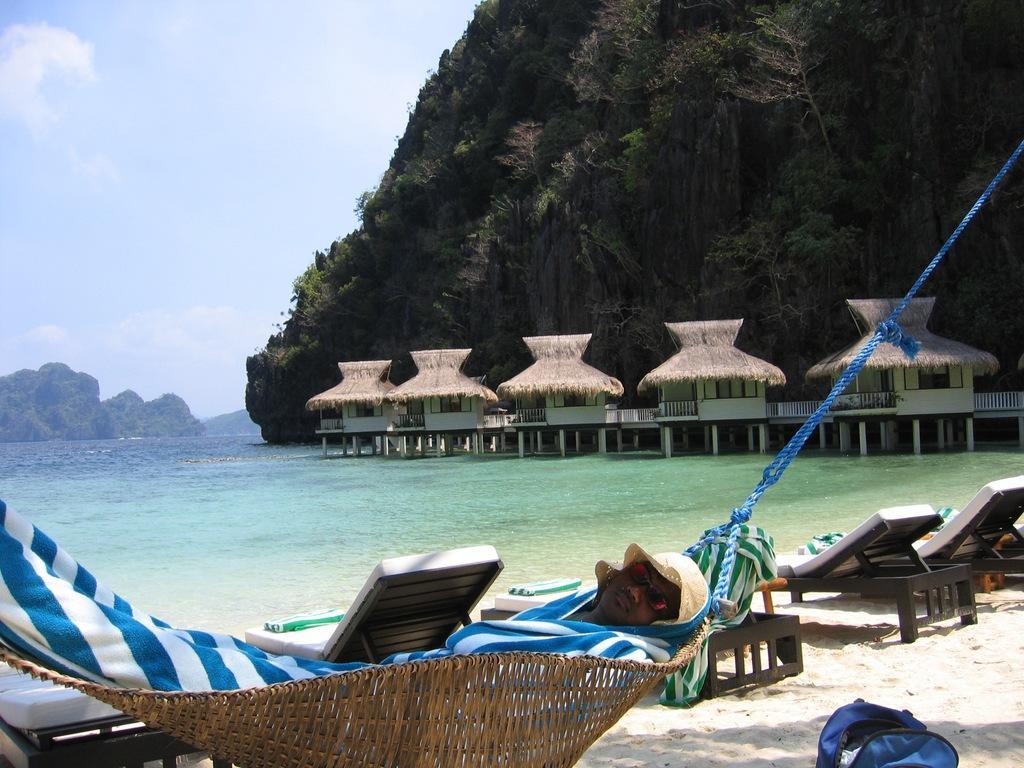How would you summarize this image in a sentence or two? In the picture we can see a beach view with a sand on it, we can see some chairs and a person sleeping and in the background, we can see the water, which is green in color and we can see some huts with pillars, hills with plants and a sky and clouds. 